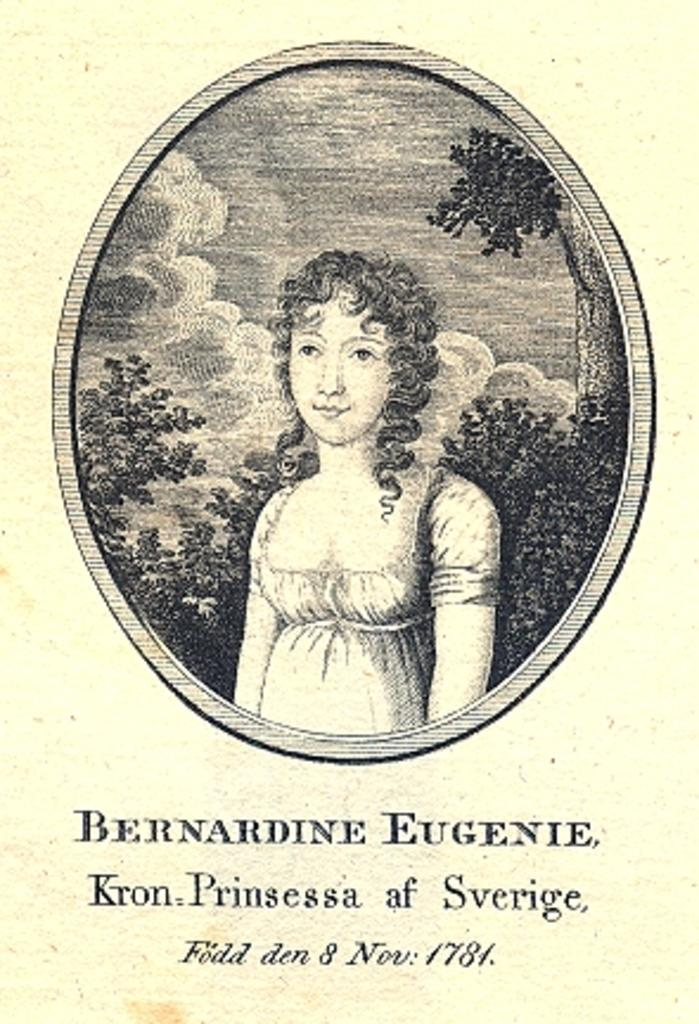What type of image is being described? The image is a poster. Who or what is the main subject of the poster? There is a girl depicted on the poster. What other elements are present on the poster? There are trees depicted on the poster. What type of trade is being taught by the girl in the poster? There is no indication of any trade or teaching in the poster; it simply depicts a girl and trees. 